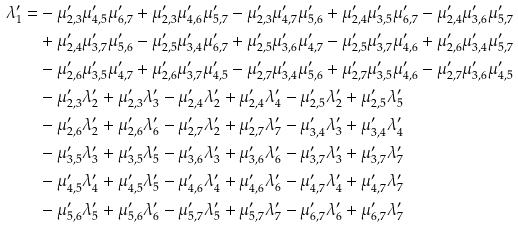Convert formula to latex. <formula><loc_0><loc_0><loc_500><loc_500>\lambda ^ { \prime } _ { 1 } = & - \mu ^ { \prime } _ { 2 , 3 } \mu ^ { \prime } _ { 4 , 5 } \mu ^ { \prime } _ { 6 , 7 } + \mu ^ { \prime } _ { 2 , 3 } \mu ^ { \prime } _ { 4 , 6 } \mu ^ { \prime } _ { 5 , 7 } - \mu ^ { \prime } _ { 2 , 3 } \mu ^ { \prime } _ { 4 , 7 } \mu ^ { \prime } _ { 5 , 6 } + \mu ^ { \prime } _ { 2 , 4 } \mu ^ { \prime } _ { 3 , 5 } \mu ^ { \prime } _ { 6 , 7 } - \mu ^ { \prime } _ { 2 , 4 } \mu ^ { \prime } _ { 3 , 6 } \mu ^ { \prime } _ { 5 , 7 } \\ & + \mu ^ { \prime } _ { 2 , 4 } \mu ^ { \prime } _ { 3 , 7 } \mu ^ { \prime } _ { 5 , 6 } - \mu ^ { \prime } _ { 2 , 5 } \mu ^ { \prime } _ { 3 , 4 } \mu ^ { \prime } _ { 6 , 7 } + \mu ^ { \prime } _ { 2 , 5 } \mu ^ { \prime } _ { 3 , 6 } \mu ^ { \prime } _ { 4 , 7 } - \mu ^ { \prime } _ { 2 , 5 } \mu ^ { \prime } _ { 3 , 7 } \mu ^ { \prime } _ { 4 , 6 } + \mu ^ { \prime } _ { 2 , 6 } \mu ^ { \prime } _ { 3 , 4 } \mu ^ { \prime } _ { 5 , 7 } \\ & - \mu ^ { \prime } _ { 2 , 6 } \mu ^ { \prime } _ { 3 , 5 } \mu ^ { \prime } _ { 4 , 7 } + \mu ^ { \prime } _ { 2 , 6 } \mu ^ { \prime } _ { 3 , 7 } \mu ^ { \prime } _ { 4 , 5 } - \mu ^ { \prime } _ { 2 , 7 } \mu ^ { \prime } _ { 3 , 4 } \mu ^ { \prime } _ { 5 , 6 } + \mu ^ { \prime } _ { 2 , 7 } \mu ^ { \prime } _ { 3 , 5 } \mu ^ { \prime } _ { 4 , 6 } - \mu ^ { \prime } _ { 2 , 7 } \mu ^ { \prime } _ { 3 , 6 } \mu ^ { \prime } _ { 4 , 5 } \\ & - \mu ^ { \prime } _ { 2 , 3 } \lambda ^ { \prime } _ { 2 } + \mu ^ { \prime } _ { 2 , 3 } \lambda ^ { \prime } _ { 3 } - \mu ^ { \prime } _ { 2 , 4 } \lambda ^ { \prime } _ { 2 } + \mu ^ { \prime } _ { 2 , 4 } \lambda ^ { \prime } _ { 4 } - \mu ^ { \prime } _ { 2 , 5 } \lambda ^ { \prime } _ { 2 } + \mu ^ { \prime } _ { 2 , 5 } \lambda ^ { \prime } _ { 5 } \\ & - \mu ^ { \prime } _ { 2 , 6 } \lambda ^ { \prime } _ { 2 } + \mu ^ { \prime } _ { 2 , 6 } \lambda ^ { \prime } _ { 6 } - \mu ^ { \prime } _ { 2 , 7 } \lambda ^ { \prime } _ { 2 } + \mu ^ { \prime } _ { 2 , 7 } \lambda ^ { \prime } _ { 7 } - \mu ^ { \prime } _ { 3 , 4 } \lambda ^ { \prime } _ { 3 } + \mu ^ { \prime } _ { 3 , 4 } \lambda ^ { \prime } _ { 4 } \\ & - \mu ^ { \prime } _ { 3 , 5 } \lambda ^ { \prime } _ { 3 } + \mu ^ { \prime } _ { 3 , 5 } \lambda ^ { \prime } _ { 5 } - \mu ^ { \prime } _ { 3 , 6 } \lambda ^ { \prime } _ { 3 } + \mu ^ { \prime } _ { 3 , 6 } \lambda ^ { \prime } _ { 6 } - \mu ^ { \prime } _ { 3 , 7 } \lambda ^ { \prime } _ { 3 } + \mu ^ { \prime } _ { 3 , 7 } \lambda ^ { \prime } _ { 7 } \\ & - \mu ^ { \prime } _ { 4 , 5 } \lambda ^ { \prime } _ { 4 } + \mu ^ { \prime } _ { 4 , 5 } \lambda ^ { \prime } _ { 5 } - \mu ^ { \prime } _ { 4 , 6 } \lambda ^ { \prime } _ { 4 } + \mu ^ { \prime } _ { 4 , 6 } \lambda ^ { \prime } _ { 6 } - \mu ^ { \prime } _ { 4 , 7 } \lambda ^ { \prime } _ { 4 } + \mu ^ { \prime } _ { 4 , 7 } \lambda ^ { \prime } _ { 7 } \\ & - \mu ^ { \prime } _ { 5 , 6 } \lambda ^ { \prime } _ { 5 } + \mu ^ { \prime } _ { 5 , 6 } \lambda ^ { \prime } _ { 6 } - \mu ^ { \prime } _ { 5 , 7 } \lambda ^ { \prime } _ { 5 } + \mu ^ { \prime } _ { 5 , 7 } \lambda ^ { \prime } _ { 7 } - \mu ^ { \prime } _ { 6 , 7 } \lambda ^ { \prime } _ { 6 } + \mu ^ { \prime } _ { 6 , 7 } \lambda ^ { \prime } _ { 7 }</formula> 